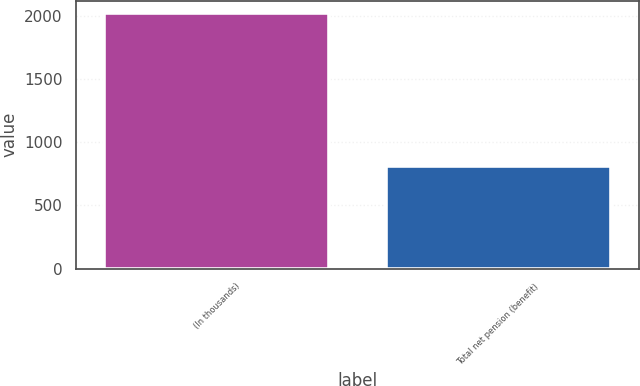Convert chart. <chart><loc_0><loc_0><loc_500><loc_500><bar_chart><fcel>(In thousands)<fcel>Total net pension (benefit)<nl><fcel>2017<fcel>811<nl></chart> 